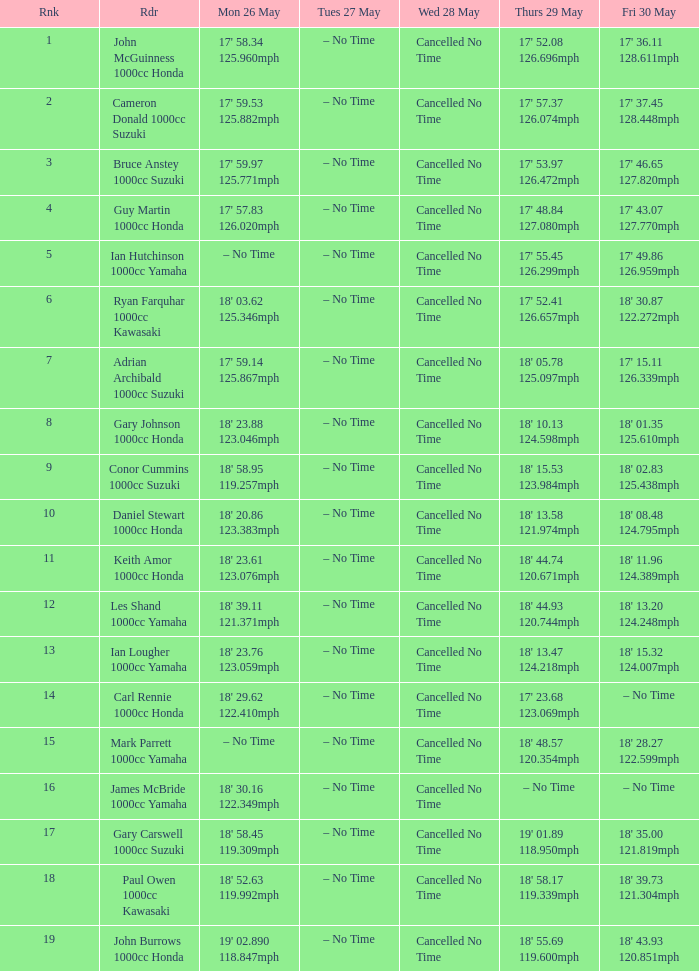What moment is wed may 28 and mon may 26, featuring 17' 5 Cancelled No Time. 